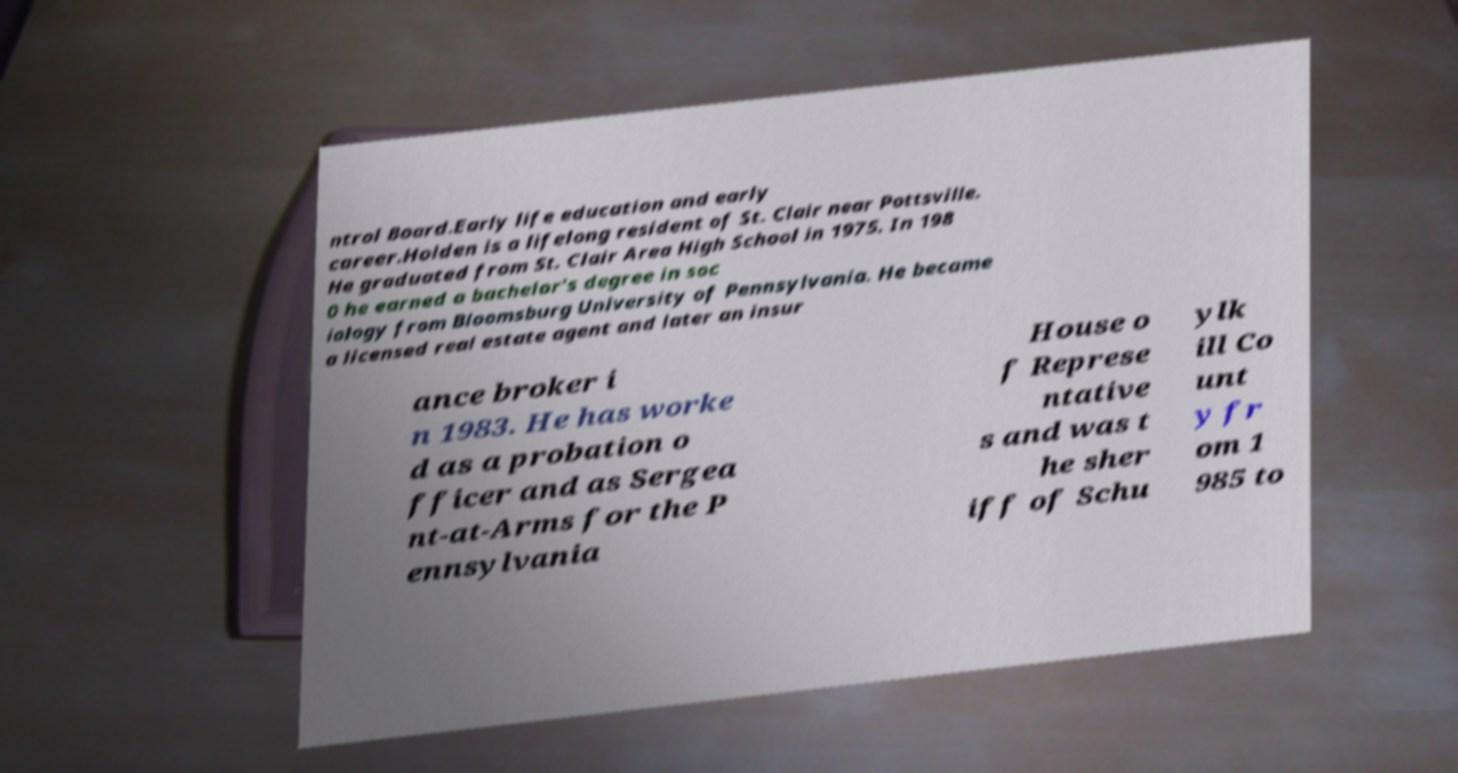Could you assist in decoding the text presented in this image and type it out clearly? ntrol Board.Early life education and early career.Holden is a lifelong resident of St. Clair near Pottsville. He graduated from St. Clair Area High School in 1975. In 198 0 he earned a bachelor's degree in soc iology from Bloomsburg University of Pennsylvania. He became a licensed real estate agent and later an insur ance broker i n 1983. He has worke d as a probation o fficer and as Sergea nt-at-Arms for the P ennsylvania House o f Represe ntative s and was t he sher iff of Schu ylk ill Co unt y fr om 1 985 to 